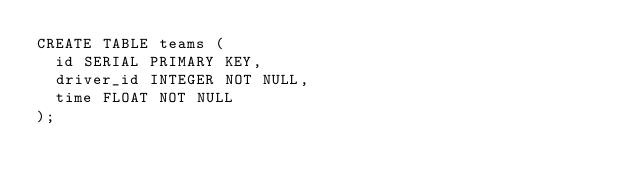Convert code to text. <code><loc_0><loc_0><loc_500><loc_500><_SQL_>CREATE TABLE teams (
  id SERIAL PRIMARY KEY,
  driver_id INTEGER NOT NULL,
  time FLOAT NOT NULL
);
</code> 